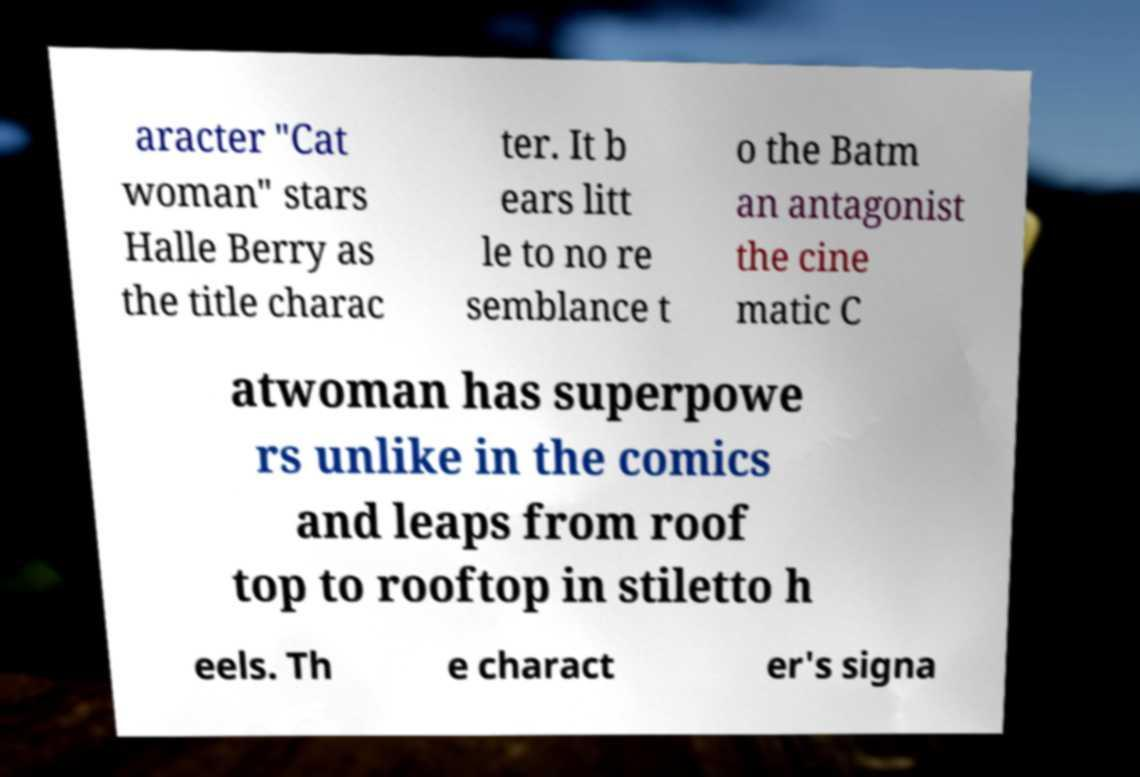Please read and relay the text visible in this image. What does it say? aracter "Cat woman" stars Halle Berry as the title charac ter. It b ears litt le to no re semblance t o the Batm an antagonist the cine matic C atwoman has superpowe rs unlike in the comics and leaps from roof top to rooftop in stiletto h eels. Th e charact er's signa 